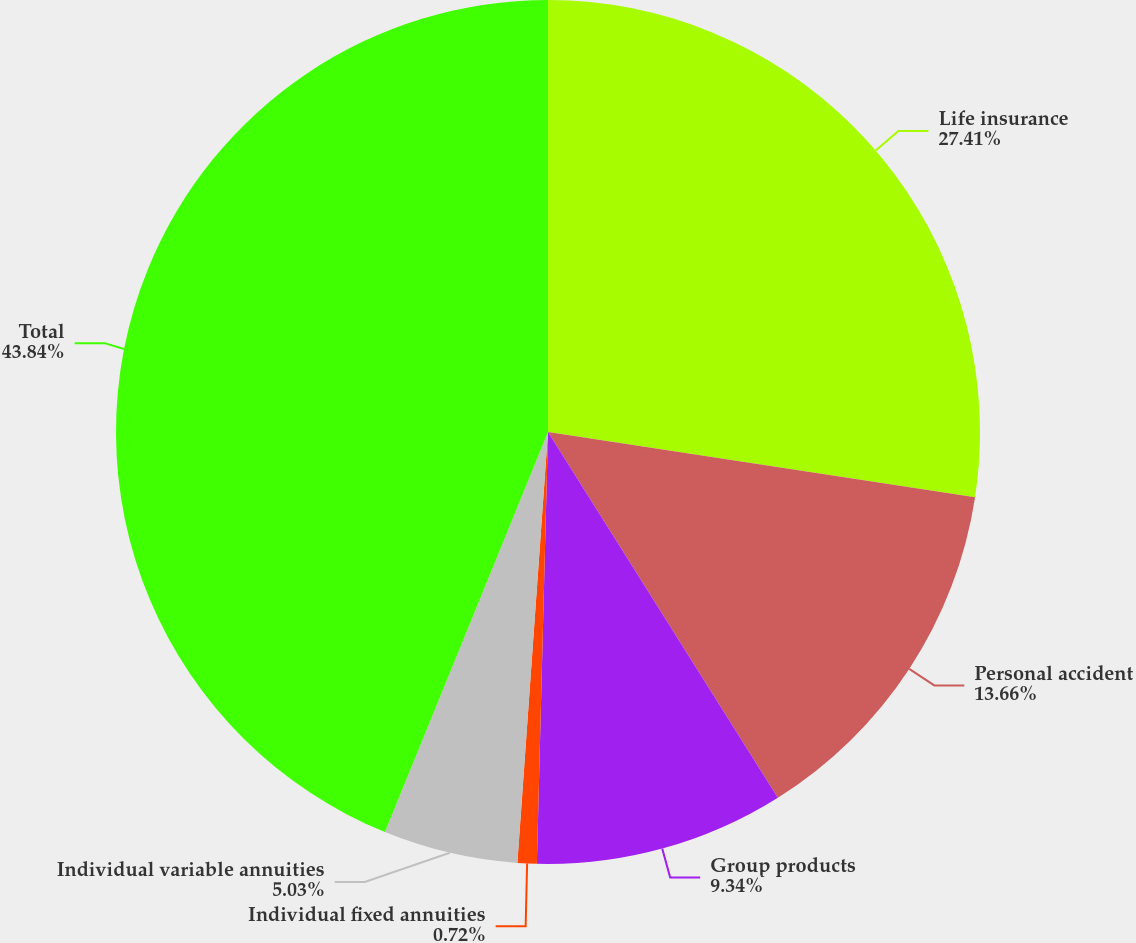<chart> <loc_0><loc_0><loc_500><loc_500><pie_chart><fcel>Life insurance<fcel>Personal accident<fcel>Group products<fcel>Individual fixed annuities<fcel>Individual variable annuities<fcel>Total<nl><fcel>27.41%<fcel>13.66%<fcel>9.34%<fcel>0.72%<fcel>5.03%<fcel>43.84%<nl></chart> 